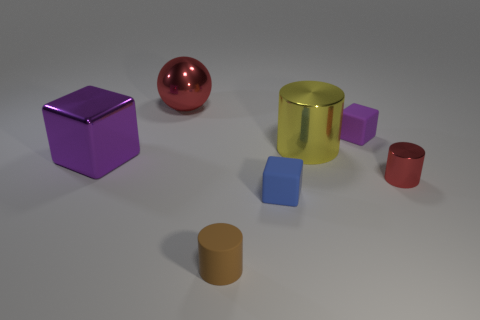The other rubber cube that is the same color as the big block is what size?
Keep it short and to the point. Small. There is a cylinder in front of the red metallic object in front of the big metal cylinder; what is its color?
Give a very brief answer. Brown. Does the yellow metallic object have the same size as the purple metallic cube?
Ensure brevity in your answer.  Yes. What number of cylinders are either things or blue objects?
Make the answer very short. 3. There is a matte object behind the tiny red metallic object; how many large yellow cylinders are left of it?
Ensure brevity in your answer.  1. Is the shape of the brown thing the same as the blue matte object?
Make the answer very short. No. What is the size of the purple metallic thing that is the same shape as the tiny blue object?
Keep it short and to the point. Large. There is a red metallic thing on the right side of the small cylinder that is on the left side of the small blue object; what shape is it?
Make the answer very short. Cylinder. What size is the red cylinder?
Offer a very short reply. Small. There is a yellow metal object; what shape is it?
Provide a succinct answer. Cylinder. 